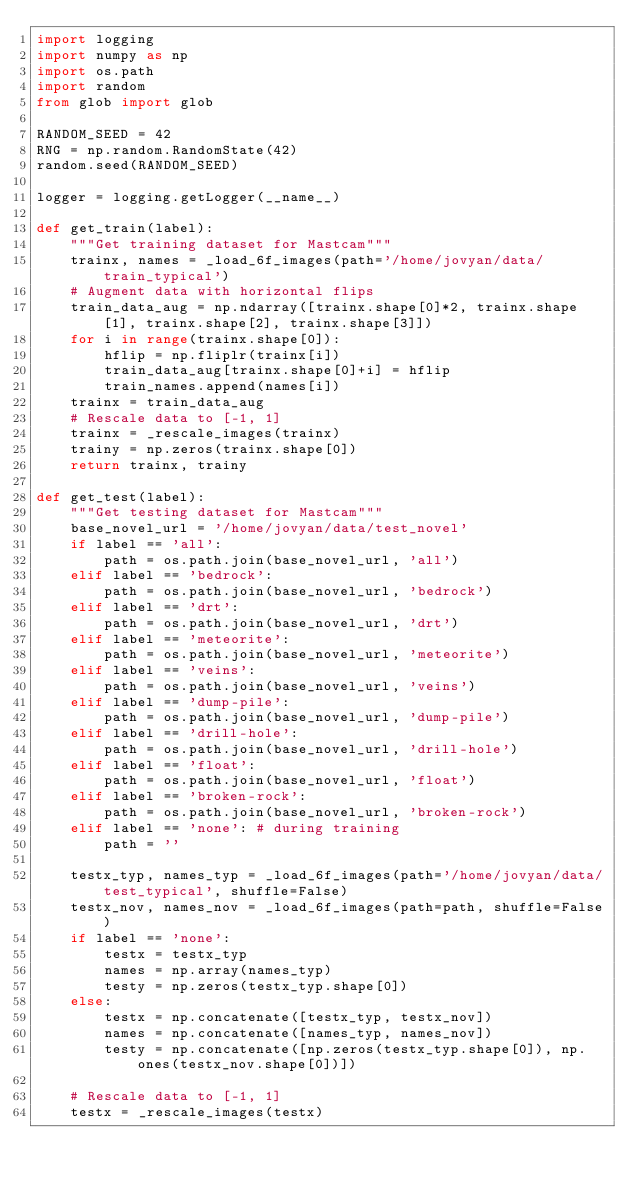Convert code to text. <code><loc_0><loc_0><loc_500><loc_500><_Python_>import logging
import numpy as np
import os.path
import random
from glob import glob

RANDOM_SEED = 42
RNG = np.random.RandomState(42)
random.seed(RANDOM_SEED)

logger = logging.getLogger(__name__)

def get_train(label):
    """Get training dataset for Mastcam"""
    trainx, names = _load_6f_images(path='/home/jovyan/data/train_typical')
    # Augment data with horizontal flips
    train_data_aug = np.ndarray([trainx.shape[0]*2, trainx.shape[1], trainx.shape[2], trainx.shape[3]])
    for i in range(trainx.shape[0]):
        hflip = np.fliplr(trainx[i])
        train_data_aug[trainx.shape[0]+i] = hflip
        train_names.append(names[i])
    trainx = train_data_aug
    # Rescale data to [-1, 1]
    trainx = _rescale_images(trainx)
    trainy = np.zeros(trainx.shape[0])
    return trainx, trainy

def get_test(label):
    """Get testing dataset for Mastcam"""
    base_novel_url = '/home/jovyan/data/test_novel'
    if label == 'all':
        path = os.path.join(base_novel_url, 'all')
    elif label == 'bedrock':
        path = os.path.join(base_novel_url, 'bedrock')
    elif label == 'drt':
        path = os.path.join(base_novel_url, 'drt')
    elif label == 'meteorite':
        path = os.path.join(base_novel_url, 'meteorite')
    elif label == 'veins':
        path = os.path.join(base_novel_url, 'veins')
    elif label == 'dump-pile':
        path = os.path.join(base_novel_url, 'dump-pile')
    elif label == 'drill-hole':
        path = os.path.join(base_novel_url, 'drill-hole')
    elif label == 'float':
        path = os.path.join(base_novel_url, 'float')
    elif label == 'broken-rock':
        path = os.path.join(base_novel_url, 'broken-rock')
    elif label == 'none': # during training
        path = ''

    testx_typ, names_typ = _load_6f_images(path='/home/jovyan/data/test_typical', shuffle=False)
    testx_nov, names_nov = _load_6f_images(path=path, shuffle=False)
    if label == 'none':
        testx = testx_typ
        names = np.array(names_typ)
        testy = np.zeros(testx_typ.shape[0])
    else:
        testx = np.concatenate([testx_typ, testx_nov])
        names = np.concatenate([names_typ, names_nov])
        testy = np.concatenate([np.zeros(testx_typ.shape[0]), np.ones(testx_nov.shape[0])])
    
    # Rescale data to [-1, 1]
    testx = _rescale_images(testx)
    </code> 